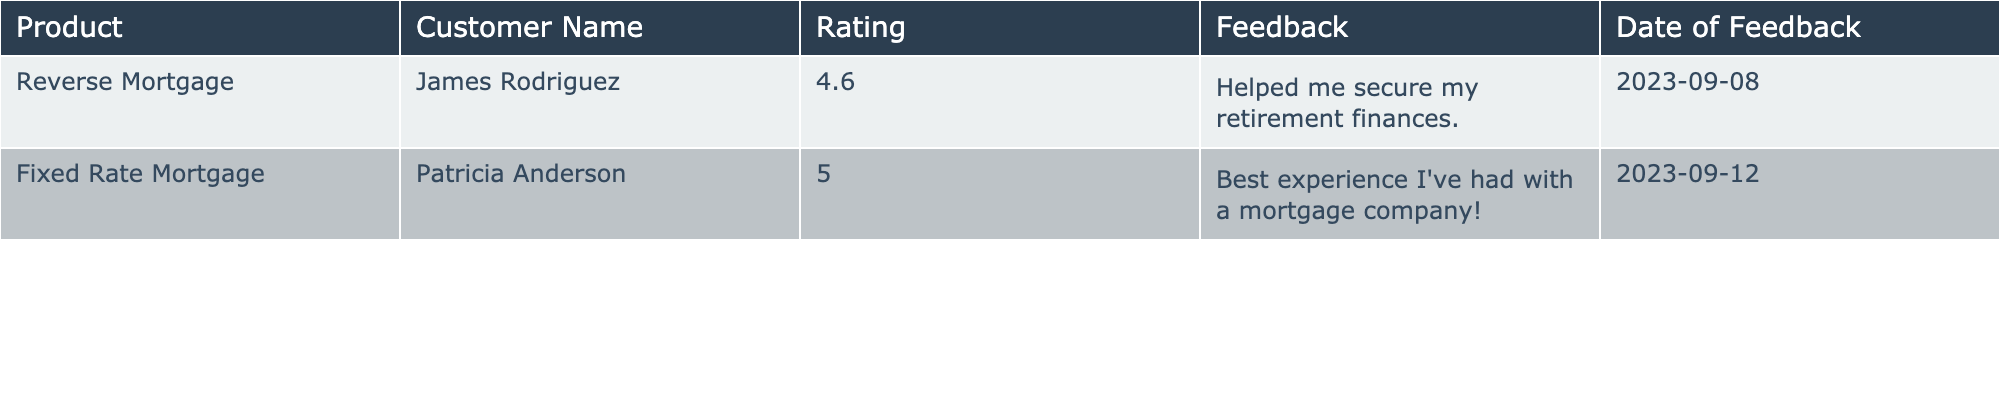What is the highest customer satisfaction rating in the table? The ratings provided are 4.6 and 5.0. The highest rating is 5.0, which is associated with the Fixed Rate Mortgage product.
Answer: 5.0 What feedback did James Rodriguez provide for the Reverse Mortgage? The feedback from James Rodriguez indicates that the mortgage helped him secure his retirement finances.
Answer: "Helped me secure my retirement finances." How many customers have rated their experience with mortgage services in the table? There are two unique customer ratings in the table, provided by James Rodriguez and Patricia Anderson.
Answer: 2 What is the average rating of the mortgage services listed? To calculate the average, add the ratings (4.6 + 5.0 = 9.6) and divide by the number of ratings (2). Thus, the average rating is 9.6 / 2 = 4.8.
Answer: 4.8 Did Patricia Anderson provide feedback about her experience? The table shows that Patricia Anderson provided a feedback comment indicating a very positive experience with the mortgage company, stating it was the best experience she's had.
Answer: Yes Which product does Patricia Anderson's feedback relate to? The feedback from Patricia Anderson relates to the Fixed Rate Mortgage, as specified in the table.
Answer: Fixed Rate Mortgage Which product received a higher average rating, if any, and what is that rating? There are only two ratings: 4.6 for Reverse Mortgage and 5.0 for Fixed Rate Mortgage. The Fixed Rate Mortgage has a higher rating of 5.0.
Answer: Fixed Rate Mortgage, 5.0 Is there any customer with a rating below 4.5 in the table? The lowest rating in the table is 4.6 for the Reverse Mortgage, which is above 4.5. Thus, no ratings are below 4.5.
Answer: No What date did Patricia Anderson provide her feedback? Patricia Anderson provided her feedback on September 12, 2023, as indicated in the table.
Answer: 2023-09-12 Which customer had the highest rating and what feedback did they provide? Patricia Anderson had the highest rating of 5.0, and her feedback was that it was the best experience she had with a mortgage company.
Answer: Patricia Anderson, "Best experience I've had with a mortgage company!" 